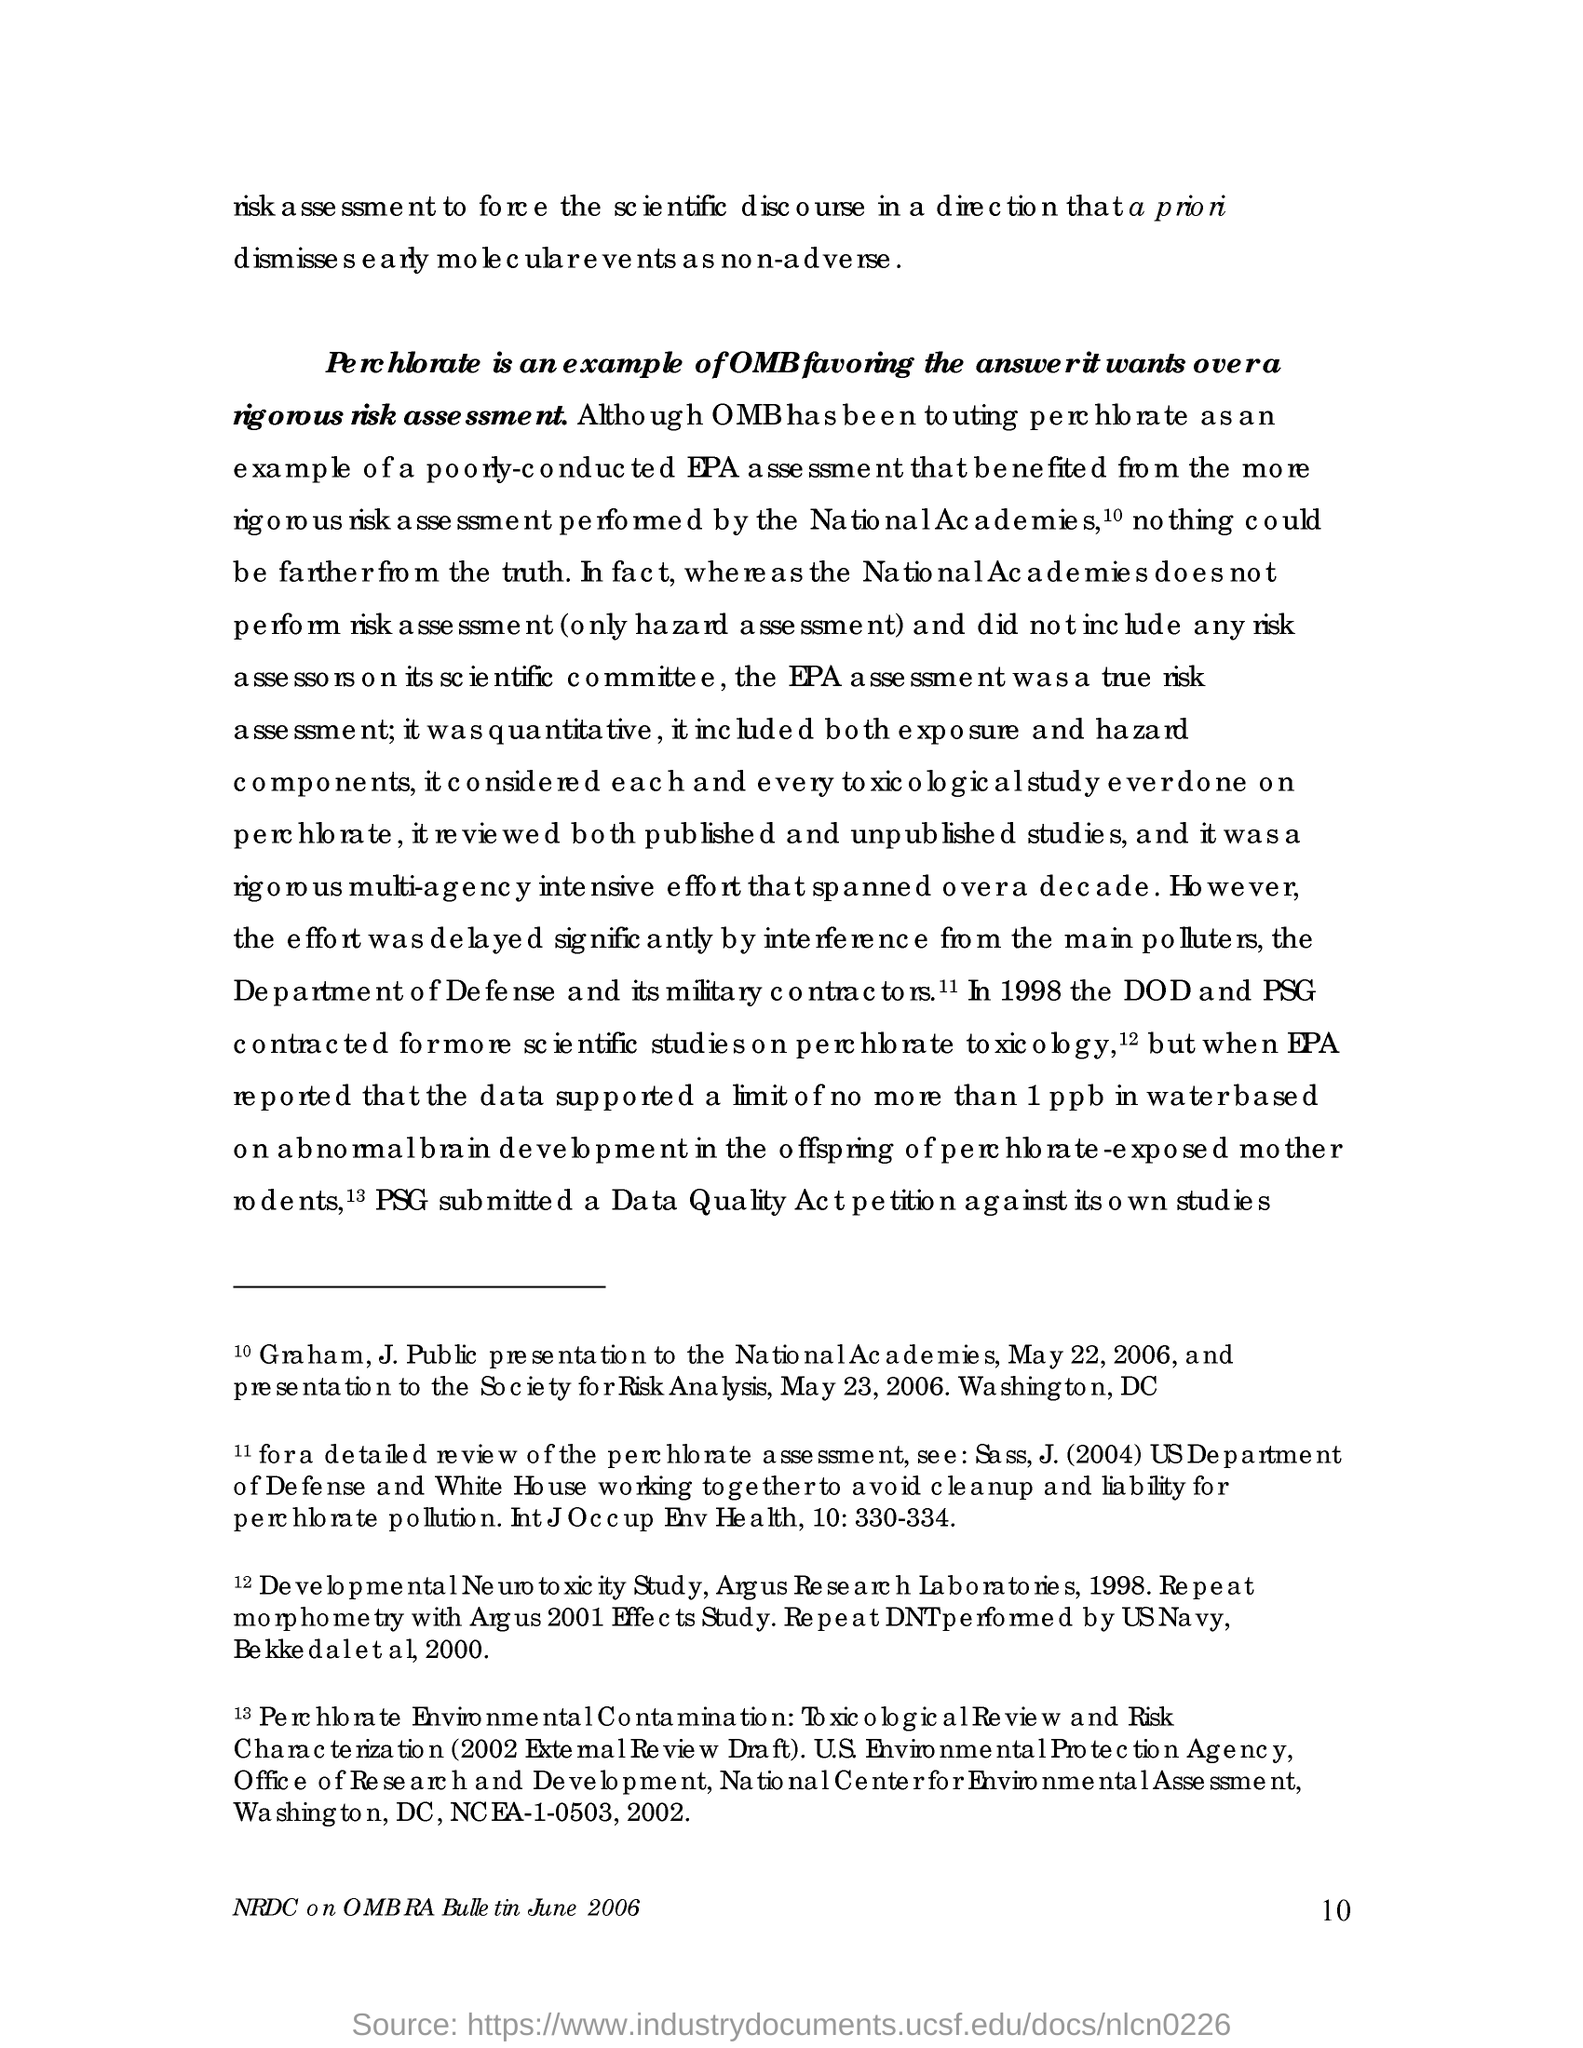What is an example of omb favouring the answer it wants over a rigour risk assesment?
Offer a very short reply. Perchlorate. By whom is the risk assesment performed?
Offer a terse response. NATIONAL ACADEMIES. Who are the main polluters?
Your response must be concise. Department of defence and its military contractors. In which year did the DOD and PSG contracted for more scientific studies on perchlorate toxicology?
Provide a short and direct response. 1998. When did graham, j. public present to the national academies?
Provide a succinct answer. May 22, 2006. 